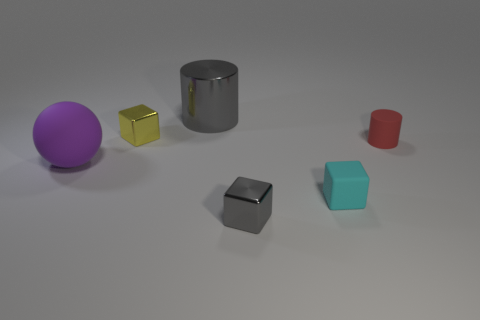What objects are reflected on the surface of the silver cylinder? Upon reviewing the image, one can observe that the reflective surface of the silver cylinder captures the distorted images of the purple sphere and the yellow cube. 